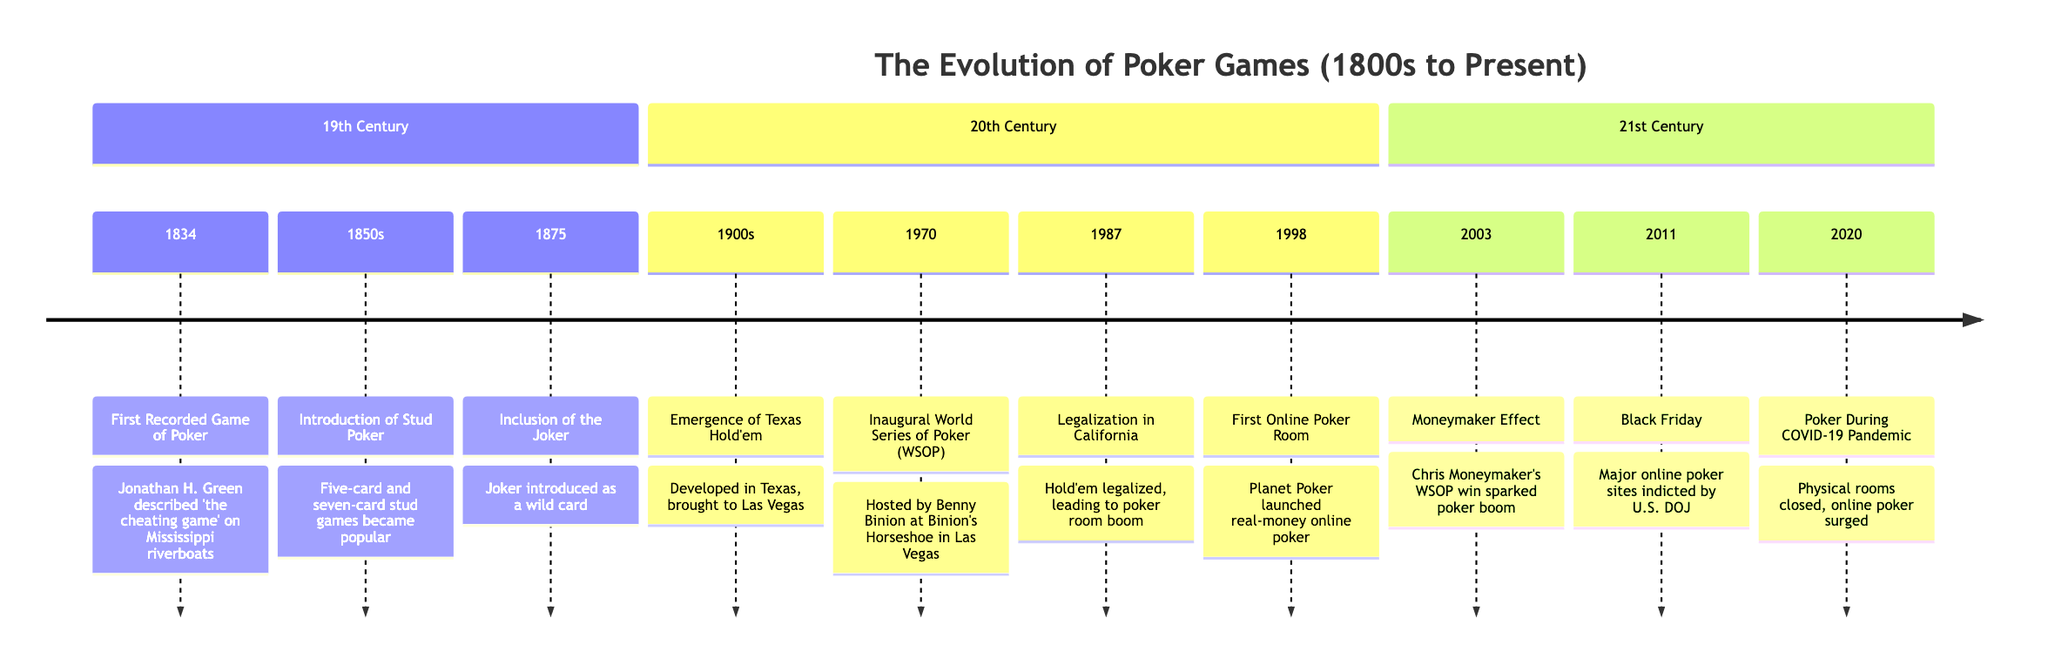What year marks the first recorded game of poker? The diagram states that the first recorded game of poker occurred in 1834. This is found at the beginning of the timeline.
Answer: 1834 What event introduced the joker as a wild card? According to the diagram, the inclusion of the joker as a wild card occurred in 1875. This is shown in the 19th Century section of the timeline.
Answer: Inclusion of the Joker How many significant events in poker are highlighted in the 20th Century section? Counting the events listed from the 1900s to 2020, there are five significant events detailed in this section of the timeline. This can be verified by counting the entries in that particular section.
Answer: 5 What prompted the surge of online poker during the COVID-19 pandemic? The timeline indicates that physical poker rooms faced closures in 2020, which led to a resurgence in online poker as players sought alternative methods to enjoy the game. This is explicitly described in the section covering the 21st Century.
Answer: Physical rooms closed Which event is associated with Chris Moneymaker? The Moneymaker Effect, as stated in the 2003 entry of the timeline, refers to Chris Moneymaker winning the WSOP Main Event. This event is pivotal in the timeline since it represents a major turning point in poker history.
Answer: Moneymaker Effect What development in poker occurred in the 1850s? The introduction of Stud Poker, specifically five-card and seven-card stud games, occurred during the 1850s as outlined in the event descriptions of the 19th Century.
Answer: Introduction of Stud Poker Which year saw the inaugural World Series of Poker? The diagram specifies that the first WSOP event took place in 1970, hosted by Benny Binion in Las Vegas. This is clearly indicated in the 20th Century section.
Answer: 1970 What major event for online poker took place in 1998? The timeline indicates that in 1998, the first online poker room, Planet Poker, was launched, marking a significant development in the history of poker. This is detailed under the 20th Century events.
Answer: First Online Poker Room 